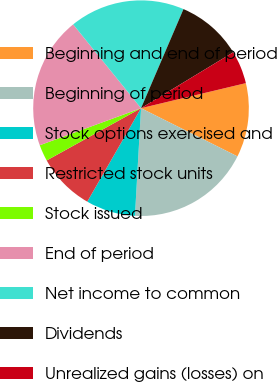Convert chart. <chart><loc_0><loc_0><loc_500><loc_500><pie_chart><fcel>Beginning and end of period<fcel>Beginning of period<fcel>Stock options exercised and<fcel>Restricted stock units<fcel>Stock issued<fcel>End of period<fcel>Net income to common<fcel>Dividends<fcel>Unrealized gains (losses) on<nl><fcel>11.11%<fcel>18.52%<fcel>7.41%<fcel>8.64%<fcel>2.47%<fcel>19.75%<fcel>17.28%<fcel>9.88%<fcel>4.94%<nl></chart> 